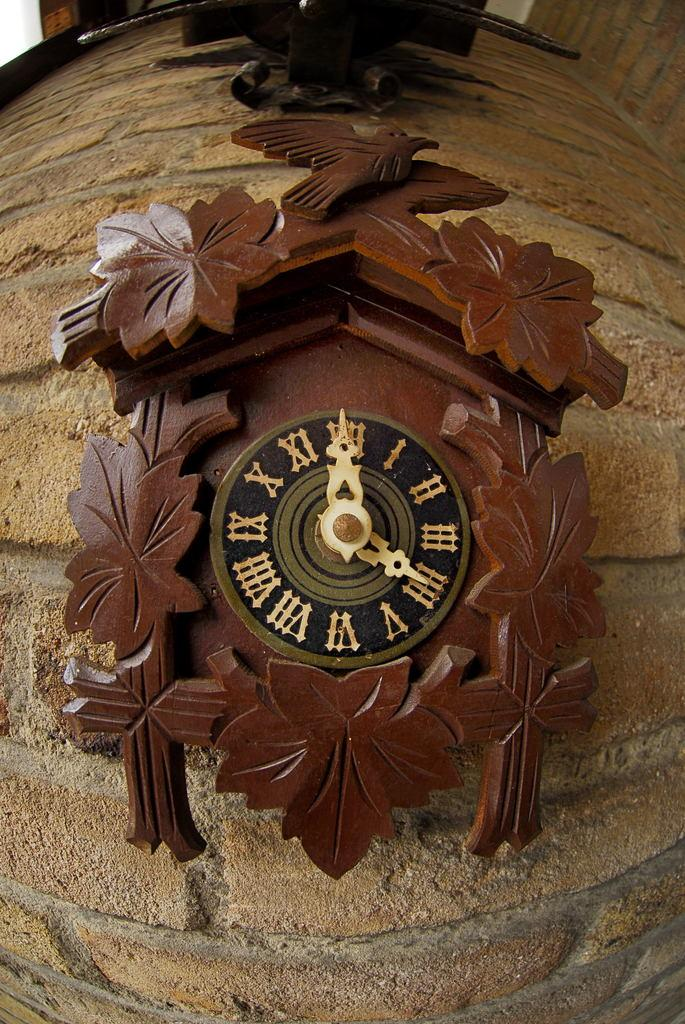What object is the main focus of the image? There is a clock in the image. Where is the clock located? The clock is on the wall. How is the clock positioned in the image? The clock is in the center of the image. What type of bean is being used to play baseball in the image? There is no bean or baseball present in the image; it only features a clock on the wall. 